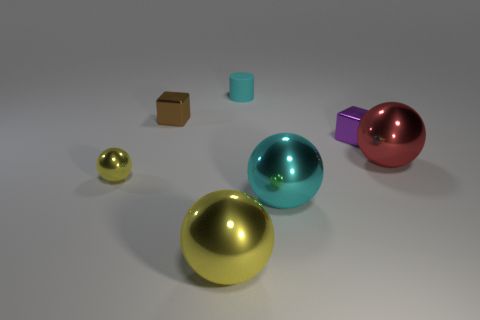Is there any other thing of the same color as the small sphere?
Offer a terse response. Yes. Is the small cylinder the same color as the tiny shiny ball?
Provide a short and direct response. No. What number of large red metallic objects are in front of the yellow ball that is in front of the small yellow thing?
Keep it short and to the point. 0. There is a object that is both behind the tiny purple cube and in front of the matte object; what size is it?
Keep it short and to the point. Small. There is a big sphere behind the cyan metal object; what is its material?
Keep it short and to the point. Metal. Is there a tiny cyan matte object that has the same shape as the small purple object?
Offer a terse response. No. How many other cyan things have the same shape as the large cyan shiny thing?
Give a very brief answer. 0. There is a cyan object that is in front of the brown thing; is it the same size as the metal block on the right side of the small cyan cylinder?
Your response must be concise. No. There is a small metallic thing that is in front of the large sphere that is behind the cyan ball; what is its shape?
Offer a very short reply. Sphere. Are there an equal number of tiny purple blocks that are behind the tiny cyan cylinder and cylinders?
Ensure brevity in your answer.  No. 